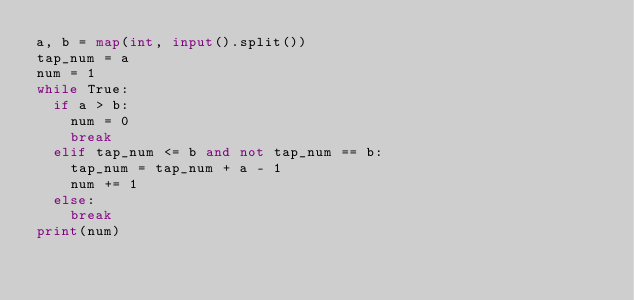<code> <loc_0><loc_0><loc_500><loc_500><_Python_>a, b = map(int, input().split())
tap_num = a
num = 1
while True:
  if a > b:
    num = 0
    break
  elif tap_num <= b and not tap_num == b:
    tap_num = tap_num + a - 1
    num += 1
  else:
    break
print(num)
</code> 